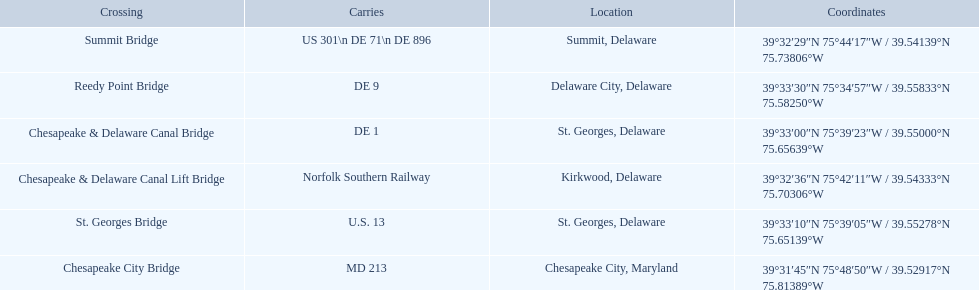Which are the bridges? Chesapeake City Bridge, Summit Bridge, Chesapeake & Delaware Canal Lift Bridge, Chesapeake & Delaware Canal Bridge, St. Georges Bridge, Reedy Point Bridge. Which are in delaware? Summit Bridge, Chesapeake & Delaware Canal Lift Bridge, Chesapeake & Delaware Canal Bridge, St. Georges Bridge, Reedy Point Bridge. Of these, which carries de 9? Reedy Point Bridge. 